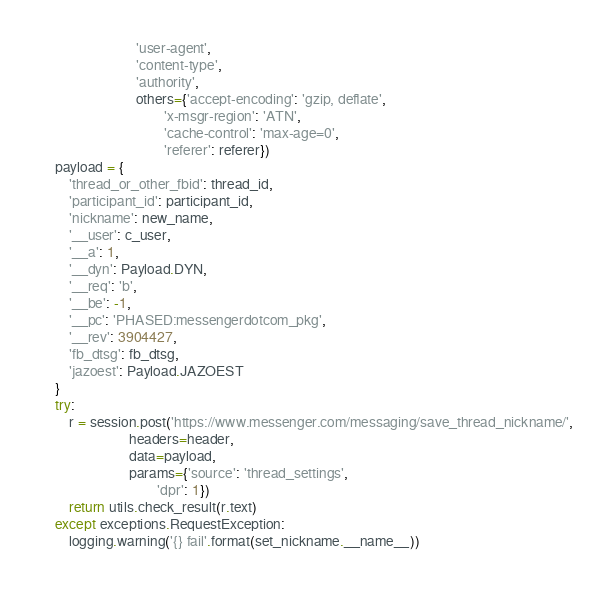<code> <loc_0><loc_0><loc_500><loc_500><_Python_>                           'user-agent',
                           'content-type',
                           'authority',
                           others={'accept-encoding': 'gzip, deflate',
                                   'x-msgr-region': 'ATN',
                                   'cache-control': 'max-age=0',
                                   'referer': referer})
    payload = {
        'thread_or_other_fbid': thread_id,
        'participant_id': participant_id,
        'nickname': new_name,
        '__user': c_user,
        '__a': 1,
        '__dyn': Payload.DYN,
        '__req': 'b',
        '__be': -1,
        '__pc': 'PHASED:messengerdotcom_pkg',
        '__rev': 3904427,
        'fb_dtsg': fb_dtsg,
        'jazoest': Payload.JAZOEST
    }
    try:
        r = session.post('https://www.messenger.com/messaging/save_thread_nickname/',
                         headers=header,
                         data=payload,
                         params={'source': 'thread_settings',
                                 'dpr': 1})
        return utils.check_result(r.text)
    except exceptions.RequestException:
        logging.warning('{} fail'.format(set_nickname.__name__))
</code> 